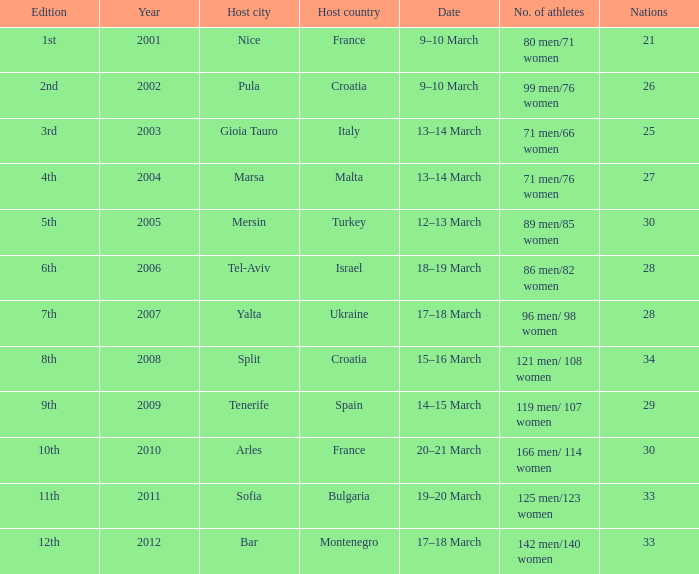In which year did montenegro serve as the host nation? 2012.0. 